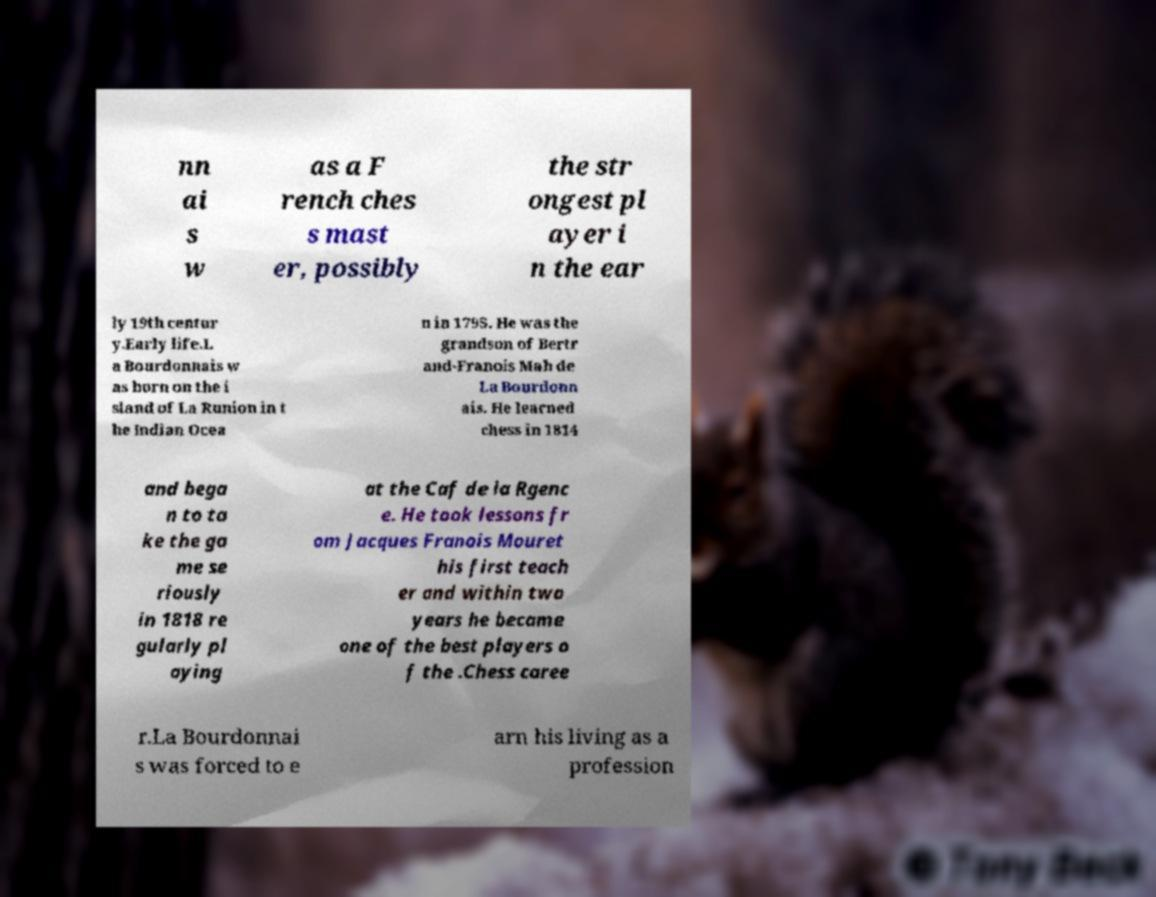Could you assist in decoding the text presented in this image and type it out clearly? nn ai s w as a F rench ches s mast er, possibly the str ongest pl ayer i n the ear ly 19th centur y.Early life.L a Bourdonnais w as born on the i sland of La Runion in t he Indian Ocea n in 1795. He was the grandson of Bertr and-Franois Mah de La Bourdonn ais. He learned chess in 1814 and bega n to ta ke the ga me se riously in 1818 re gularly pl aying at the Caf de la Rgenc e. He took lessons fr om Jacques Franois Mouret his first teach er and within two years he became one of the best players o f the .Chess caree r.La Bourdonnai s was forced to e arn his living as a profession 